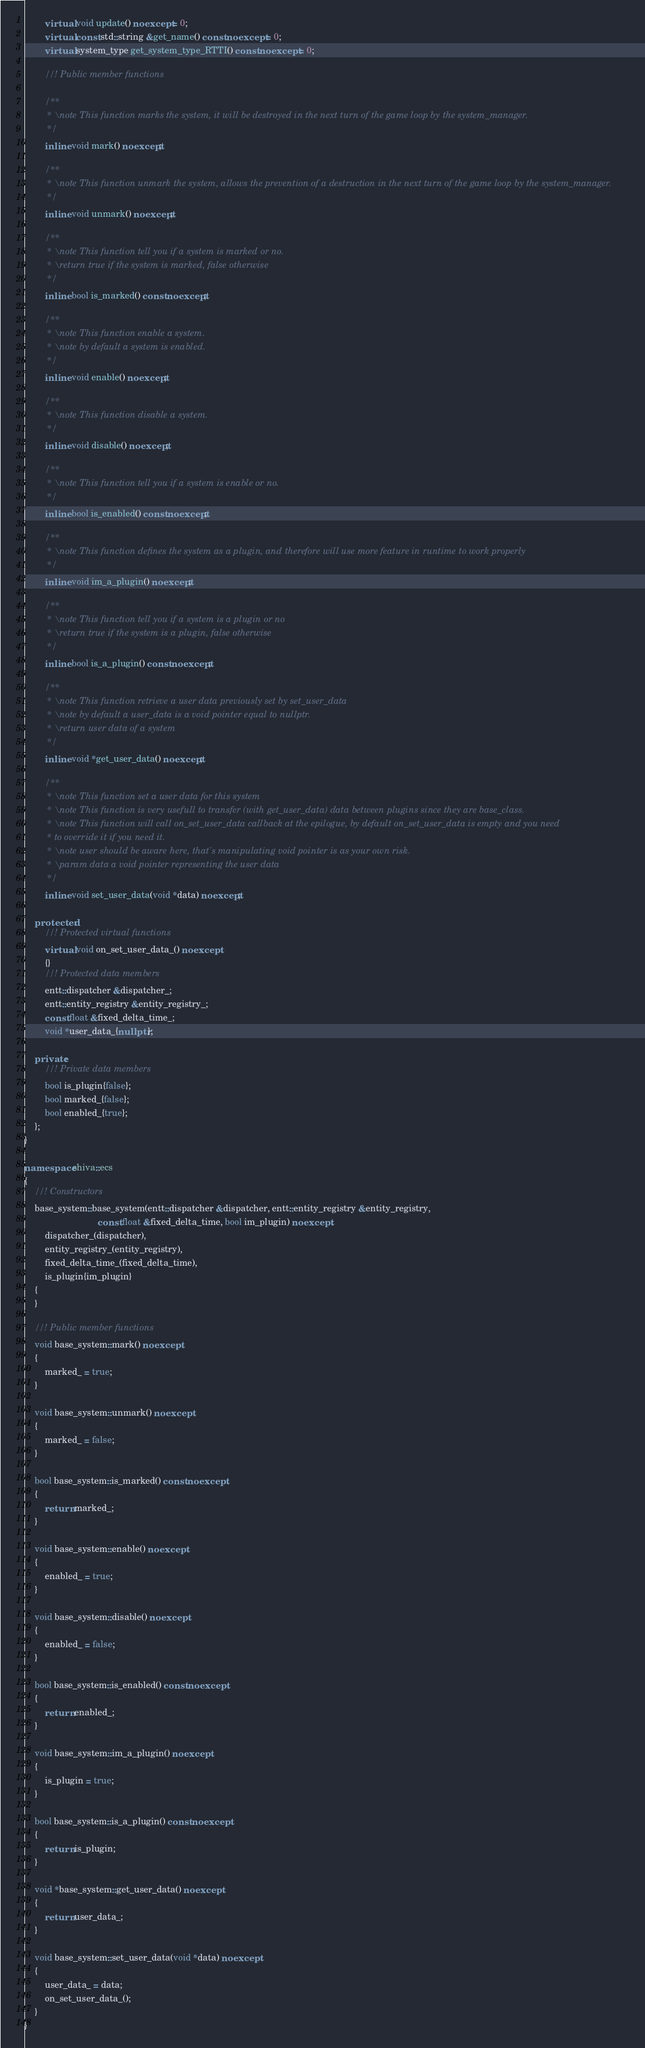<code> <loc_0><loc_0><loc_500><loc_500><_C++_>        virtual void update() noexcept = 0;
        virtual const std::string &get_name() const noexcept = 0;
        virtual system_type get_system_type_RTTI() const noexcept = 0;

        //! Public member functions

        /**
         * \note This function marks the system, it will be destroyed in the next turn of the game loop by the system_manager.
         */
        inline void mark() noexcept;

        /**
         * \note This function unmark the system, allows the prevention of a destruction in the next turn of the game loop by the system_manager.
         */
        inline void unmark() noexcept;

        /**
         * \note This function tell you if a system is marked or no.
         * \return true if the system is marked, false otherwise
         */
        inline bool is_marked() const noexcept;

        /**
         * \note This function enable a system.
         * \note by default a system is enabled.
         */
        inline void enable() noexcept;

        /**
         * \note This function disable a system.
         */
        inline void disable() noexcept;

        /**
         * \note This function tell you if a system is enable or no.
         */
        inline bool is_enabled() const noexcept;

        /**
         * \note This function defines the system as a plugin, and therefore will use more feature in runtime to work properly
         */
        inline void im_a_plugin() noexcept;

        /**
         * \note This function tell you if a system is a plugin or no
         * \return true if the system is a plugin, false otherwise
         */
        inline bool is_a_plugin() const noexcept;

        /**
         * \note This function retrieve a user data previously set by set_user_data
         * \note by default a user_data is a void pointer equal to nullptr.
         * \return user data of a system
         */
        inline void *get_user_data() noexcept;

        /**
         * \note This function set a user data for this system
         * \note This function is very usefull to transfer (with get_user_data) data between plugins since they are base_class.
         * \note This function will call on_set_user_data callback at the epilogue, by default on_set_user_data is empty and you need
         * to override it if you need it.
         * \note user should be aware here, that's manipulating void pointer is as your own risk.
         * \param data a void pointer representing the user data
         */
        inline void set_user_data(void *data) noexcept;

    protected:
        //! Protected virtual functions
        virtual void on_set_user_data_() noexcept
        {}
        //! Protected data members
        entt::dispatcher &dispatcher_;
        entt::entity_registry &entity_registry_;
        const float &fixed_delta_time_;
        void *user_data_{nullptr};

    private:
        //! Private data members
        bool is_plugin{false};
        bool marked_{false};
        bool enabled_{true};
    };
}

namespace shiva::ecs
{
    //! Constructors
    base_system::base_system(entt::dispatcher &dispatcher, entt::entity_registry &entity_registry,
                             const float &fixed_delta_time, bool im_plugin) noexcept :
        dispatcher_(dispatcher),
        entity_registry_(entity_registry),
        fixed_delta_time_(fixed_delta_time),
        is_plugin{im_plugin}
    {
    }

    //! Public member functions
    void base_system::mark() noexcept
    {
        marked_ = true;
    }

    void base_system::unmark() noexcept
    {
        marked_ = false;
    }

    bool base_system::is_marked() const noexcept
    {
        return marked_;
    }

    void base_system::enable() noexcept
    {
        enabled_ = true;
    }

    void base_system::disable() noexcept
    {
        enabled_ = false;
    }

    bool base_system::is_enabled() const noexcept
    {
        return enabled_;
    }

    void base_system::im_a_plugin() noexcept
    {
        is_plugin = true;
    }

    bool base_system::is_a_plugin() const noexcept
    {
        return is_plugin;
    }

    void *base_system::get_user_data() noexcept
    {
        return user_data_;
    }

    void base_system::set_user_data(void *data) noexcept
    {
        user_data_ = data;
        on_set_user_data_();
    }
}</code> 